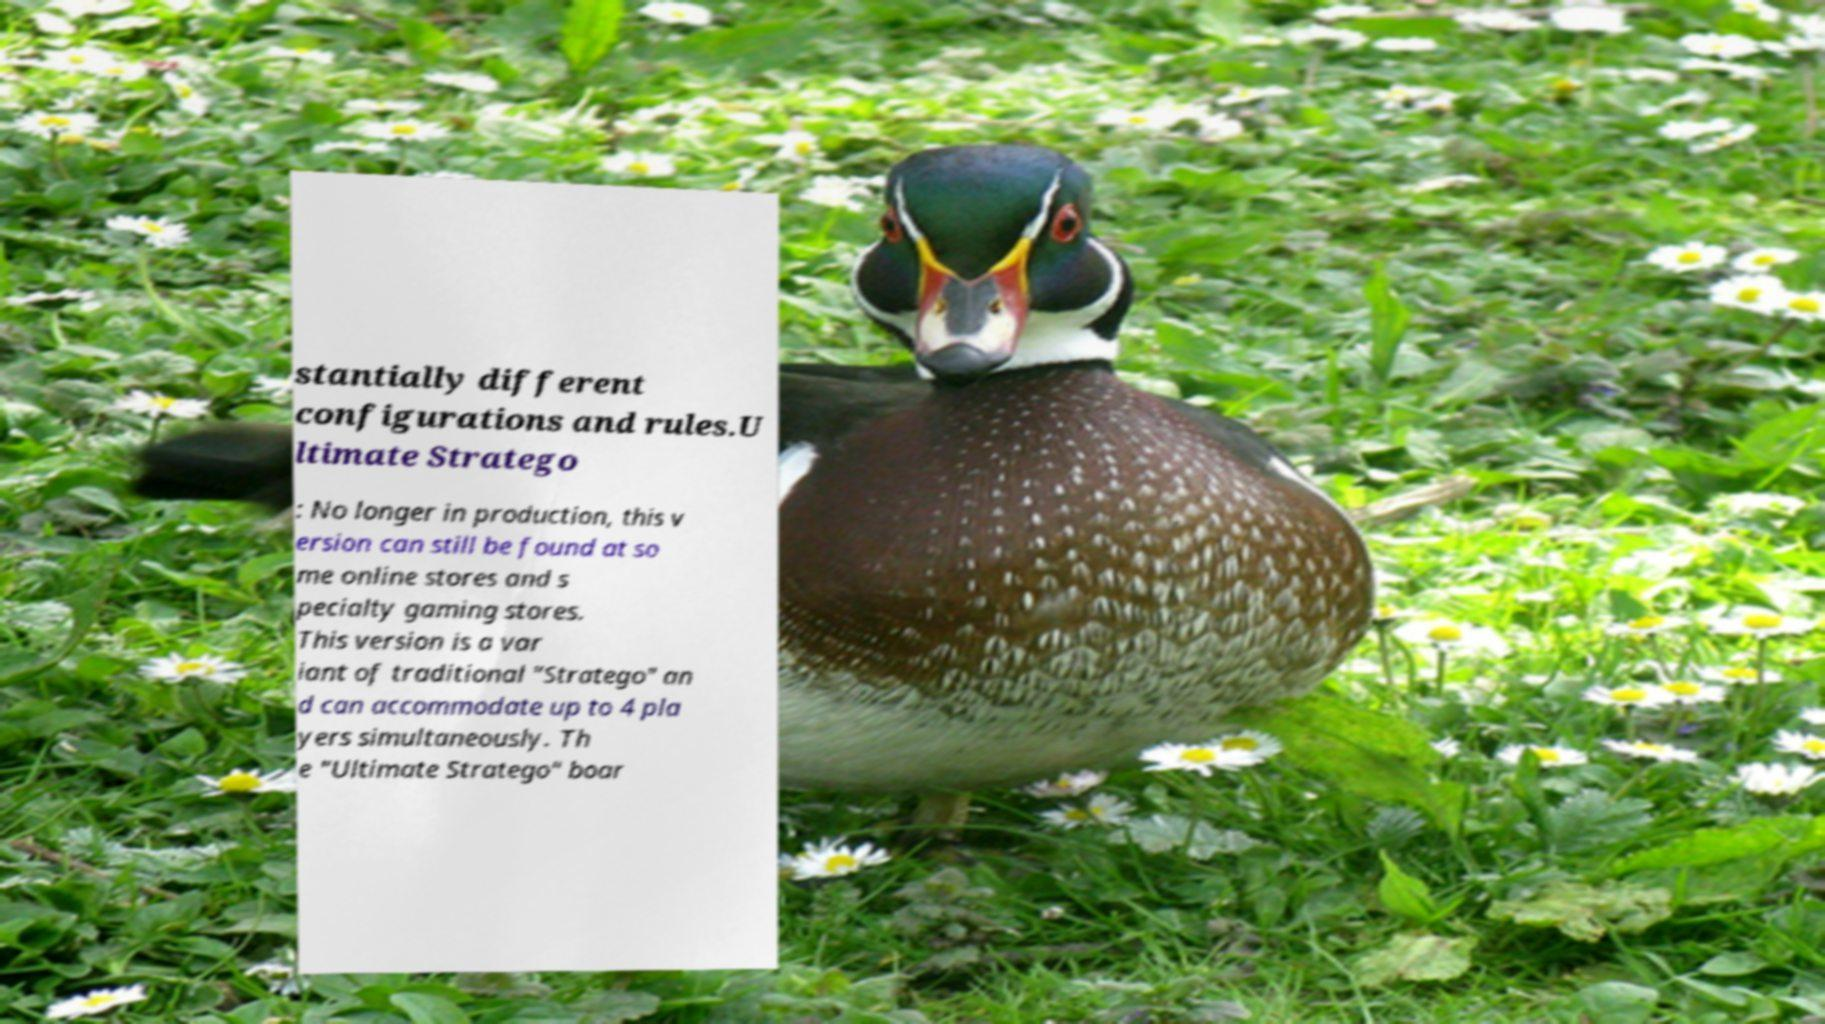What messages or text are displayed in this image? I need them in a readable, typed format. stantially different configurations and rules.U ltimate Stratego : No longer in production, this v ersion can still be found at so me online stores and s pecialty gaming stores. This version is a var iant of traditional "Stratego" an d can accommodate up to 4 pla yers simultaneously. Th e "Ultimate Stratego" boar 